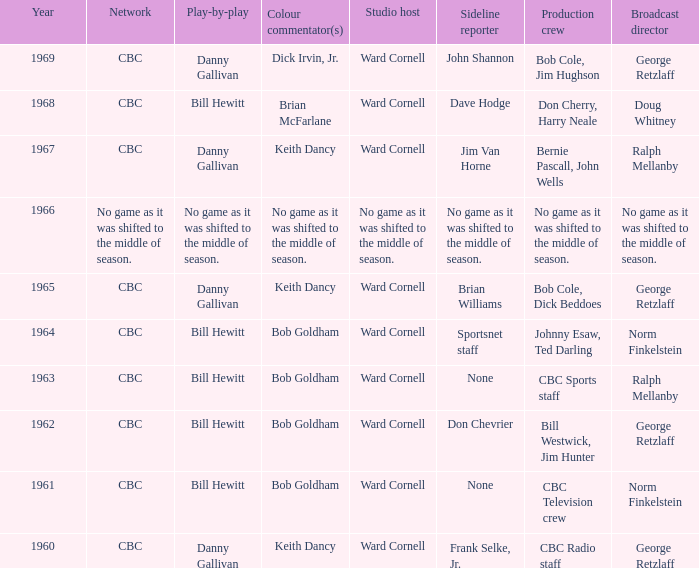Who gave the play by play commentary with studio host Ward Cornell? Danny Gallivan, Bill Hewitt, Danny Gallivan, Danny Gallivan, Bill Hewitt, Bill Hewitt, Bill Hewitt, Bill Hewitt, Danny Gallivan. 